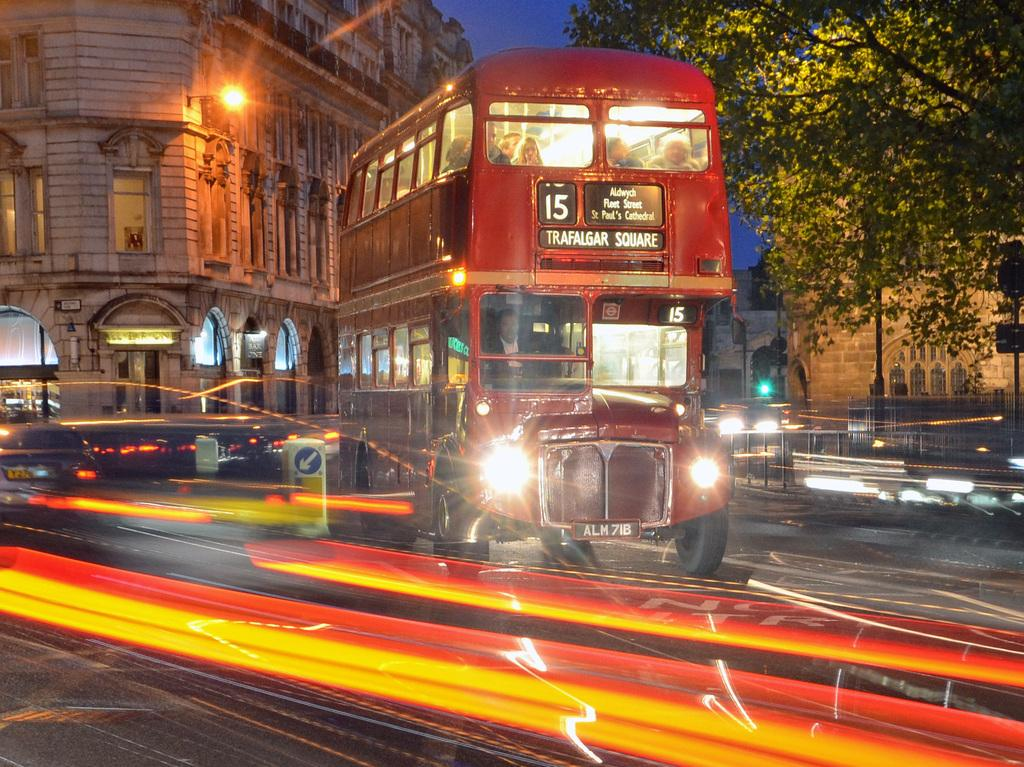What type of vehicle is present in the image? There is a bus in the image. Are there any other vehicles in the image? Yes, there is a car in the image. Where are the bus and car located? Both the bus and car are on the road in the image. What other structures can be seen in the image? There is a fence, lights, buildings with windows, and a tree in the image. What is visible in the background of the image? The sky is visible in the background of the image. Can you tell me how many snails are crawling on the bus in the image? There are no snails present in the image; it only features a bus, a car, and other structures. 